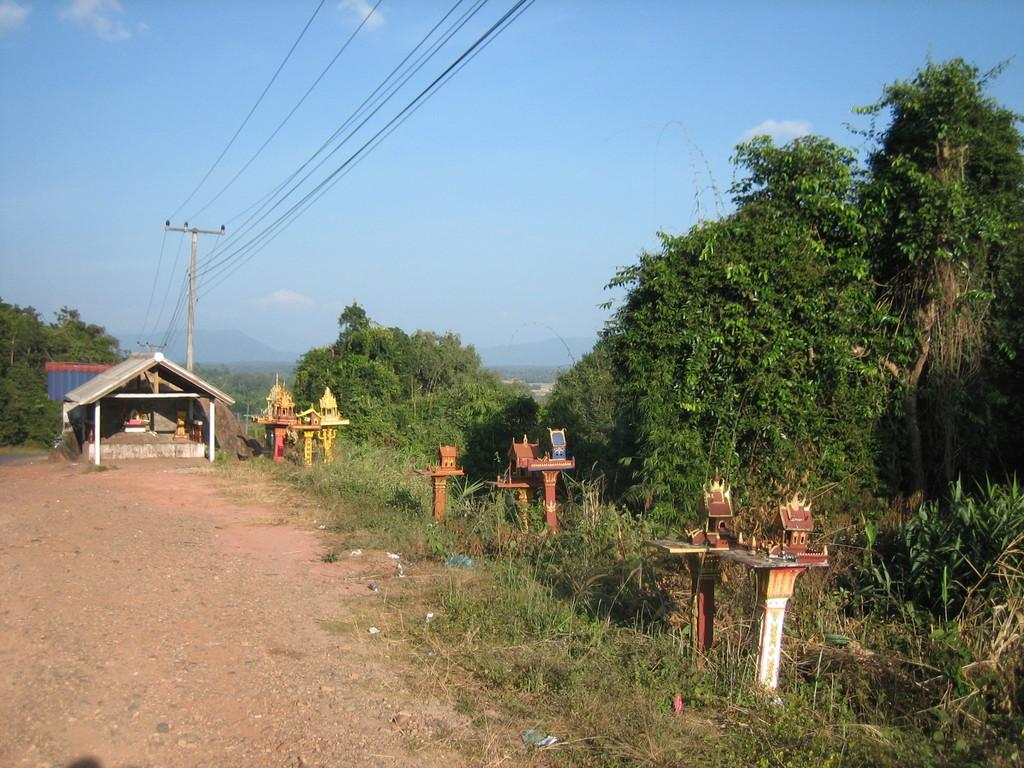What type of vegetation is present in the image? There are trees in the image. What color are the trees? The trees are green. What can be seen in the background of the image? There are poles, a shed, and an electric pole in the background of the image. What is the color of the shed? The shed is white. How many colors are visible on the poles in the background? The poles have multiple colors. What is the color of the sky in the image? The sky is blue and white. Can you hear the son talking about the steam coming from the electric pole in the image? There is no son or steam present in the image, and therefore no such conversation can be heard. 